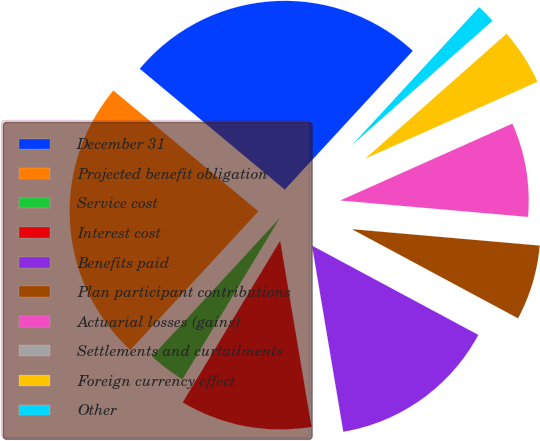Convert chart. <chart><loc_0><loc_0><loc_500><loc_500><pie_chart><fcel>December 31<fcel>Projected benefit obligation<fcel>Service cost<fcel>Interest cost<fcel>Benefits paid<fcel>Plan participant contributions<fcel>Actuarial losses (gains)<fcel>Settlements and curtailments<fcel>Foreign currency effect<fcel>Other<nl><fcel>25.8%<fcel>24.19%<fcel>3.23%<fcel>11.29%<fcel>14.51%<fcel>6.45%<fcel>8.07%<fcel>0.0%<fcel>4.84%<fcel>1.62%<nl></chart> 